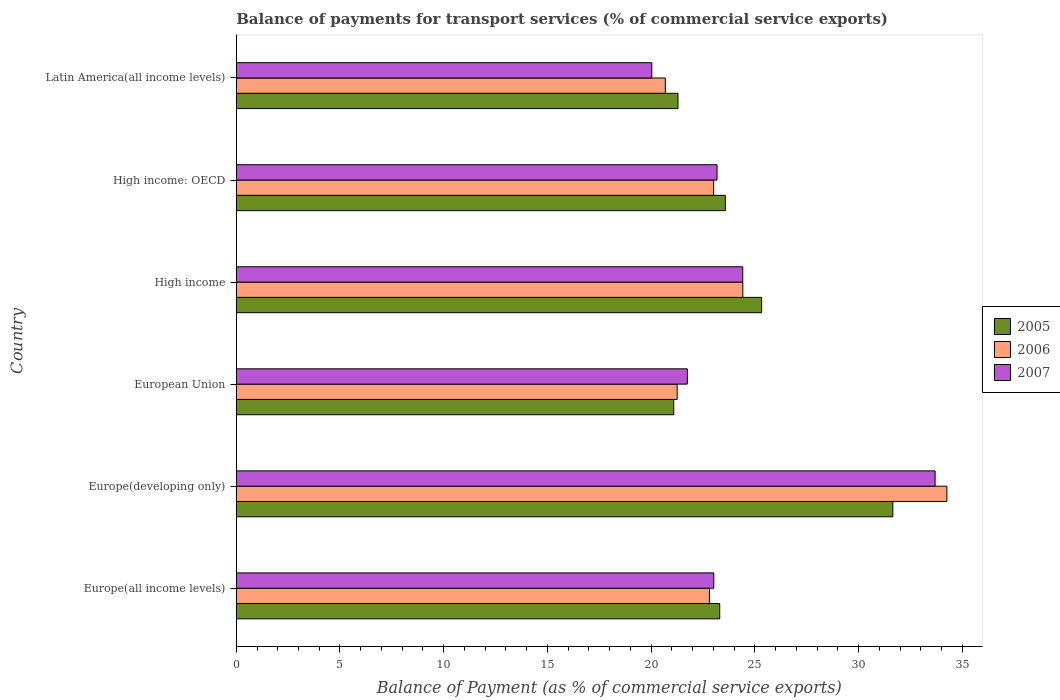Are the number of bars on each tick of the Y-axis equal?
Your response must be concise. Yes. How many bars are there on the 3rd tick from the bottom?
Give a very brief answer. 3. What is the label of the 5th group of bars from the top?
Provide a succinct answer. Europe(developing only). What is the balance of payments for transport services in 2007 in High income?
Provide a short and direct response. 24.42. Across all countries, what is the maximum balance of payments for transport services in 2007?
Your answer should be compact. 33.69. Across all countries, what is the minimum balance of payments for transport services in 2007?
Keep it short and to the point. 20.03. In which country was the balance of payments for transport services in 2006 maximum?
Your response must be concise. Europe(developing only). What is the total balance of payments for transport services in 2007 in the graph?
Ensure brevity in your answer.  146.08. What is the difference between the balance of payments for transport services in 2006 in Europe(all income levels) and that in High income?
Provide a succinct answer. -1.61. What is the difference between the balance of payments for transport services in 2006 in High income: OECD and the balance of payments for transport services in 2005 in Latin America(all income levels)?
Give a very brief answer. 1.72. What is the average balance of payments for transport services in 2005 per country?
Ensure brevity in your answer.  24.37. What is the difference between the balance of payments for transport services in 2007 and balance of payments for transport services in 2005 in High income: OECD?
Provide a short and direct response. -0.4. In how many countries, is the balance of payments for transport services in 2006 greater than 26 %?
Give a very brief answer. 1. What is the ratio of the balance of payments for transport services in 2006 in Europe(developing only) to that in High income: OECD?
Make the answer very short. 1.49. Is the balance of payments for transport services in 2007 in High income: OECD less than that in Latin America(all income levels)?
Your response must be concise. No. What is the difference between the highest and the second highest balance of payments for transport services in 2006?
Keep it short and to the point. 9.84. What is the difference between the highest and the lowest balance of payments for transport services in 2005?
Offer a terse response. 10.56. What does the 2nd bar from the top in High income represents?
Make the answer very short. 2006. Is it the case that in every country, the sum of the balance of payments for transport services in 2005 and balance of payments for transport services in 2006 is greater than the balance of payments for transport services in 2007?
Make the answer very short. Yes. Are all the bars in the graph horizontal?
Your answer should be very brief. Yes. How many countries are there in the graph?
Ensure brevity in your answer.  6. Does the graph contain any zero values?
Your answer should be very brief. No. Does the graph contain grids?
Ensure brevity in your answer.  No. How are the legend labels stacked?
Make the answer very short. Vertical. What is the title of the graph?
Keep it short and to the point. Balance of payments for transport services (% of commercial service exports). Does "1998" appear as one of the legend labels in the graph?
Offer a terse response. No. What is the label or title of the X-axis?
Your answer should be very brief. Balance of Payment (as % of commercial service exports). What is the Balance of Payment (as % of commercial service exports) of 2005 in Europe(all income levels)?
Offer a terse response. 23.31. What is the Balance of Payment (as % of commercial service exports) in 2006 in Europe(all income levels)?
Provide a short and direct response. 22.81. What is the Balance of Payment (as % of commercial service exports) in 2007 in Europe(all income levels)?
Provide a short and direct response. 23.02. What is the Balance of Payment (as % of commercial service exports) of 2005 in Europe(developing only)?
Provide a short and direct response. 31.65. What is the Balance of Payment (as % of commercial service exports) of 2006 in Europe(developing only)?
Your answer should be very brief. 34.26. What is the Balance of Payment (as % of commercial service exports) of 2007 in Europe(developing only)?
Offer a terse response. 33.69. What is the Balance of Payment (as % of commercial service exports) in 2005 in European Union?
Provide a short and direct response. 21.09. What is the Balance of Payment (as % of commercial service exports) of 2006 in European Union?
Give a very brief answer. 21.25. What is the Balance of Payment (as % of commercial service exports) of 2007 in European Union?
Make the answer very short. 21.74. What is the Balance of Payment (as % of commercial service exports) in 2005 in High income?
Provide a succinct answer. 25.33. What is the Balance of Payment (as % of commercial service exports) of 2006 in High income?
Provide a succinct answer. 24.42. What is the Balance of Payment (as % of commercial service exports) of 2007 in High income?
Offer a very short reply. 24.42. What is the Balance of Payment (as % of commercial service exports) of 2005 in High income: OECD?
Offer a very short reply. 23.58. What is the Balance of Payment (as % of commercial service exports) in 2006 in High income: OECD?
Offer a terse response. 23.01. What is the Balance of Payment (as % of commercial service exports) in 2007 in High income: OECD?
Offer a terse response. 23.18. What is the Balance of Payment (as % of commercial service exports) of 2005 in Latin America(all income levels)?
Provide a short and direct response. 21.29. What is the Balance of Payment (as % of commercial service exports) of 2006 in Latin America(all income levels)?
Keep it short and to the point. 20.68. What is the Balance of Payment (as % of commercial service exports) of 2007 in Latin America(all income levels)?
Offer a very short reply. 20.03. Across all countries, what is the maximum Balance of Payment (as % of commercial service exports) of 2005?
Your answer should be very brief. 31.65. Across all countries, what is the maximum Balance of Payment (as % of commercial service exports) in 2006?
Provide a succinct answer. 34.26. Across all countries, what is the maximum Balance of Payment (as % of commercial service exports) in 2007?
Keep it short and to the point. 33.69. Across all countries, what is the minimum Balance of Payment (as % of commercial service exports) of 2005?
Your answer should be compact. 21.09. Across all countries, what is the minimum Balance of Payment (as % of commercial service exports) in 2006?
Offer a very short reply. 20.68. Across all countries, what is the minimum Balance of Payment (as % of commercial service exports) of 2007?
Keep it short and to the point. 20.03. What is the total Balance of Payment (as % of commercial service exports) in 2005 in the graph?
Your answer should be very brief. 146.25. What is the total Balance of Payment (as % of commercial service exports) of 2006 in the graph?
Ensure brevity in your answer.  146.44. What is the total Balance of Payment (as % of commercial service exports) of 2007 in the graph?
Provide a short and direct response. 146.08. What is the difference between the Balance of Payment (as % of commercial service exports) in 2005 in Europe(all income levels) and that in Europe(developing only)?
Keep it short and to the point. -8.35. What is the difference between the Balance of Payment (as % of commercial service exports) of 2006 in Europe(all income levels) and that in Europe(developing only)?
Your answer should be compact. -11.45. What is the difference between the Balance of Payment (as % of commercial service exports) in 2007 in Europe(all income levels) and that in Europe(developing only)?
Your response must be concise. -10.67. What is the difference between the Balance of Payment (as % of commercial service exports) in 2005 in Europe(all income levels) and that in European Union?
Your answer should be compact. 2.22. What is the difference between the Balance of Payment (as % of commercial service exports) in 2006 in Europe(all income levels) and that in European Union?
Keep it short and to the point. 1.55. What is the difference between the Balance of Payment (as % of commercial service exports) of 2007 in Europe(all income levels) and that in European Union?
Your answer should be very brief. 1.28. What is the difference between the Balance of Payment (as % of commercial service exports) in 2005 in Europe(all income levels) and that in High income?
Ensure brevity in your answer.  -2.02. What is the difference between the Balance of Payment (as % of commercial service exports) in 2006 in Europe(all income levels) and that in High income?
Your response must be concise. -1.61. What is the difference between the Balance of Payment (as % of commercial service exports) of 2007 in Europe(all income levels) and that in High income?
Offer a terse response. -1.4. What is the difference between the Balance of Payment (as % of commercial service exports) in 2005 in Europe(all income levels) and that in High income: OECD?
Offer a terse response. -0.27. What is the difference between the Balance of Payment (as % of commercial service exports) in 2006 in Europe(all income levels) and that in High income: OECD?
Offer a very short reply. -0.2. What is the difference between the Balance of Payment (as % of commercial service exports) of 2007 in Europe(all income levels) and that in High income: OECD?
Keep it short and to the point. -0.16. What is the difference between the Balance of Payment (as % of commercial service exports) in 2005 in Europe(all income levels) and that in Latin America(all income levels)?
Your answer should be very brief. 2.01. What is the difference between the Balance of Payment (as % of commercial service exports) in 2006 in Europe(all income levels) and that in Latin America(all income levels)?
Provide a short and direct response. 2.13. What is the difference between the Balance of Payment (as % of commercial service exports) of 2007 in Europe(all income levels) and that in Latin America(all income levels)?
Offer a very short reply. 2.99. What is the difference between the Balance of Payment (as % of commercial service exports) in 2005 in Europe(developing only) and that in European Union?
Make the answer very short. 10.56. What is the difference between the Balance of Payment (as % of commercial service exports) in 2006 in Europe(developing only) and that in European Union?
Your answer should be compact. 13. What is the difference between the Balance of Payment (as % of commercial service exports) in 2007 in Europe(developing only) and that in European Union?
Ensure brevity in your answer.  11.94. What is the difference between the Balance of Payment (as % of commercial service exports) in 2005 in Europe(developing only) and that in High income?
Your answer should be compact. 6.33. What is the difference between the Balance of Payment (as % of commercial service exports) of 2006 in Europe(developing only) and that in High income?
Provide a short and direct response. 9.84. What is the difference between the Balance of Payment (as % of commercial service exports) of 2007 in Europe(developing only) and that in High income?
Ensure brevity in your answer.  9.27. What is the difference between the Balance of Payment (as % of commercial service exports) of 2005 in Europe(developing only) and that in High income: OECD?
Your answer should be compact. 8.07. What is the difference between the Balance of Payment (as % of commercial service exports) in 2006 in Europe(developing only) and that in High income: OECD?
Keep it short and to the point. 11.25. What is the difference between the Balance of Payment (as % of commercial service exports) in 2007 in Europe(developing only) and that in High income: OECD?
Your answer should be compact. 10.51. What is the difference between the Balance of Payment (as % of commercial service exports) in 2005 in Europe(developing only) and that in Latin America(all income levels)?
Offer a very short reply. 10.36. What is the difference between the Balance of Payment (as % of commercial service exports) of 2006 in Europe(developing only) and that in Latin America(all income levels)?
Give a very brief answer. 13.57. What is the difference between the Balance of Payment (as % of commercial service exports) in 2007 in Europe(developing only) and that in Latin America(all income levels)?
Your answer should be compact. 13.66. What is the difference between the Balance of Payment (as % of commercial service exports) in 2005 in European Union and that in High income?
Keep it short and to the point. -4.24. What is the difference between the Balance of Payment (as % of commercial service exports) of 2006 in European Union and that in High income?
Keep it short and to the point. -3.17. What is the difference between the Balance of Payment (as % of commercial service exports) in 2007 in European Union and that in High income?
Your answer should be very brief. -2.67. What is the difference between the Balance of Payment (as % of commercial service exports) of 2005 in European Union and that in High income: OECD?
Offer a terse response. -2.49. What is the difference between the Balance of Payment (as % of commercial service exports) of 2006 in European Union and that in High income: OECD?
Make the answer very short. -1.76. What is the difference between the Balance of Payment (as % of commercial service exports) in 2007 in European Union and that in High income: OECD?
Provide a short and direct response. -1.43. What is the difference between the Balance of Payment (as % of commercial service exports) of 2005 in European Union and that in Latin America(all income levels)?
Make the answer very short. -0.21. What is the difference between the Balance of Payment (as % of commercial service exports) of 2006 in European Union and that in Latin America(all income levels)?
Your answer should be compact. 0.57. What is the difference between the Balance of Payment (as % of commercial service exports) of 2007 in European Union and that in Latin America(all income levels)?
Provide a short and direct response. 1.71. What is the difference between the Balance of Payment (as % of commercial service exports) of 2005 in High income and that in High income: OECD?
Ensure brevity in your answer.  1.75. What is the difference between the Balance of Payment (as % of commercial service exports) in 2006 in High income and that in High income: OECD?
Your response must be concise. 1.41. What is the difference between the Balance of Payment (as % of commercial service exports) in 2007 in High income and that in High income: OECD?
Give a very brief answer. 1.24. What is the difference between the Balance of Payment (as % of commercial service exports) of 2005 in High income and that in Latin America(all income levels)?
Your answer should be compact. 4.03. What is the difference between the Balance of Payment (as % of commercial service exports) of 2006 in High income and that in Latin America(all income levels)?
Provide a short and direct response. 3.74. What is the difference between the Balance of Payment (as % of commercial service exports) in 2007 in High income and that in Latin America(all income levels)?
Make the answer very short. 4.38. What is the difference between the Balance of Payment (as % of commercial service exports) in 2005 in High income: OECD and that in Latin America(all income levels)?
Make the answer very short. 2.28. What is the difference between the Balance of Payment (as % of commercial service exports) in 2006 in High income: OECD and that in Latin America(all income levels)?
Give a very brief answer. 2.33. What is the difference between the Balance of Payment (as % of commercial service exports) of 2007 in High income: OECD and that in Latin America(all income levels)?
Give a very brief answer. 3.15. What is the difference between the Balance of Payment (as % of commercial service exports) in 2005 in Europe(all income levels) and the Balance of Payment (as % of commercial service exports) in 2006 in Europe(developing only)?
Your response must be concise. -10.95. What is the difference between the Balance of Payment (as % of commercial service exports) of 2005 in Europe(all income levels) and the Balance of Payment (as % of commercial service exports) of 2007 in Europe(developing only)?
Provide a succinct answer. -10.38. What is the difference between the Balance of Payment (as % of commercial service exports) of 2006 in Europe(all income levels) and the Balance of Payment (as % of commercial service exports) of 2007 in Europe(developing only)?
Offer a terse response. -10.88. What is the difference between the Balance of Payment (as % of commercial service exports) in 2005 in Europe(all income levels) and the Balance of Payment (as % of commercial service exports) in 2006 in European Union?
Your answer should be compact. 2.05. What is the difference between the Balance of Payment (as % of commercial service exports) in 2005 in Europe(all income levels) and the Balance of Payment (as % of commercial service exports) in 2007 in European Union?
Your answer should be compact. 1.56. What is the difference between the Balance of Payment (as % of commercial service exports) in 2006 in Europe(all income levels) and the Balance of Payment (as % of commercial service exports) in 2007 in European Union?
Your response must be concise. 1.06. What is the difference between the Balance of Payment (as % of commercial service exports) of 2005 in Europe(all income levels) and the Balance of Payment (as % of commercial service exports) of 2006 in High income?
Your response must be concise. -1.11. What is the difference between the Balance of Payment (as % of commercial service exports) of 2005 in Europe(all income levels) and the Balance of Payment (as % of commercial service exports) of 2007 in High income?
Your response must be concise. -1.11. What is the difference between the Balance of Payment (as % of commercial service exports) of 2006 in Europe(all income levels) and the Balance of Payment (as % of commercial service exports) of 2007 in High income?
Make the answer very short. -1.61. What is the difference between the Balance of Payment (as % of commercial service exports) of 2005 in Europe(all income levels) and the Balance of Payment (as % of commercial service exports) of 2006 in High income: OECD?
Ensure brevity in your answer.  0.29. What is the difference between the Balance of Payment (as % of commercial service exports) in 2005 in Europe(all income levels) and the Balance of Payment (as % of commercial service exports) in 2007 in High income: OECD?
Your response must be concise. 0.13. What is the difference between the Balance of Payment (as % of commercial service exports) of 2006 in Europe(all income levels) and the Balance of Payment (as % of commercial service exports) of 2007 in High income: OECD?
Provide a succinct answer. -0.37. What is the difference between the Balance of Payment (as % of commercial service exports) in 2005 in Europe(all income levels) and the Balance of Payment (as % of commercial service exports) in 2006 in Latin America(all income levels)?
Offer a very short reply. 2.62. What is the difference between the Balance of Payment (as % of commercial service exports) in 2005 in Europe(all income levels) and the Balance of Payment (as % of commercial service exports) in 2007 in Latin America(all income levels)?
Give a very brief answer. 3.27. What is the difference between the Balance of Payment (as % of commercial service exports) in 2006 in Europe(all income levels) and the Balance of Payment (as % of commercial service exports) in 2007 in Latin America(all income levels)?
Make the answer very short. 2.78. What is the difference between the Balance of Payment (as % of commercial service exports) of 2005 in Europe(developing only) and the Balance of Payment (as % of commercial service exports) of 2006 in European Union?
Offer a terse response. 10.4. What is the difference between the Balance of Payment (as % of commercial service exports) of 2005 in Europe(developing only) and the Balance of Payment (as % of commercial service exports) of 2007 in European Union?
Your answer should be compact. 9.91. What is the difference between the Balance of Payment (as % of commercial service exports) of 2006 in Europe(developing only) and the Balance of Payment (as % of commercial service exports) of 2007 in European Union?
Make the answer very short. 12.51. What is the difference between the Balance of Payment (as % of commercial service exports) of 2005 in Europe(developing only) and the Balance of Payment (as % of commercial service exports) of 2006 in High income?
Your answer should be compact. 7.23. What is the difference between the Balance of Payment (as % of commercial service exports) of 2005 in Europe(developing only) and the Balance of Payment (as % of commercial service exports) of 2007 in High income?
Keep it short and to the point. 7.24. What is the difference between the Balance of Payment (as % of commercial service exports) in 2006 in Europe(developing only) and the Balance of Payment (as % of commercial service exports) in 2007 in High income?
Offer a terse response. 9.84. What is the difference between the Balance of Payment (as % of commercial service exports) in 2005 in Europe(developing only) and the Balance of Payment (as % of commercial service exports) in 2006 in High income: OECD?
Make the answer very short. 8.64. What is the difference between the Balance of Payment (as % of commercial service exports) in 2005 in Europe(developing only) and the Balance of Payment (as % of commercial service exports) in 2007 in High income: OECD?
Make the answer very short. 8.48. What is the difference between the Balance of Payment (as % of commercial service exports) of 2006 in Europe(developing only) and the Balance of Payment (as % of commercial service exports) of 2007 in High income: OECD?
Keep it short and to the point. 11.08. What is the difference between the Balance of Payment (as % of commercial service exports) in 2005 in Europe(developing only) and the Balance of Payment (as % of commercial service exports) in 2006 in Latin America(all income levels)?
Your answer should be very brief. 10.97. What is the difference between the Balance of Payment (as % of commercial service exports) of 2005 in Europe(developing only) and the Balance of Payment (as % of commercial service exports) of 2007 in Latin America(all income levels)?
Your response must be concise. 11.62. What is the difference between the Balance of Payment (as % of commercial service exports) of 2006 in Europe(developing only) and the Balance of Payment (as % of commercial service exports) of 2007 in Latin America(all income levels)?
Offer a very short reply. 14.23. What is the difference between the Balance of Payment (as % of commercial service exports) of 2005 in European Union and the Balance of Payment (as % of commercial service exports) of 2006 in High income?
Ensure brevity in your answer.  -3.33. What is the difference between the Balance of Payment (as % of commercial service exports) in 2005 in European Union and the Balance of Payment (as % of commercial service exports) in 2007 in High income?
Ensure brevity in your answer.  -3.33. What is the difference between the Balance of Payment (as % of commercial service exports) in 2006 in European Union and the Balance of Payment (as % of commercial service exports) in 2007 in High income?
Your response must be concise. -3.16. What is the difference between the Balance of Payment (as % of commercial service exports) of 2005 in European Union and the Balance of Payment (as % of commercial service exports) of 2006 in High income: OECD?
Provide a succinct answer. -1.92. What is the difference between the Balance of Payment (as % of commercial service exports) in 2005 in European Union and the Balance of Payment (as % of commercial service exports) in 2007 in High income: OECD?
Offer a very short reply. -2.09. What is the difference between the Balance of Payment (as % of commercial service exports) in 2006 in European Union and the Balance of Payment (as % of commercial service exports) in 2007 in High income: OECD?
Your answer should be very brief. -1.92. What is the difference between the Balance of Payment (as % of commercial service exports) in 2005 in European Union and the Balance of Payment (as % of commercial service exports) in 2006 in Latin America(all income levels)?
Make the answer very short. 0.41. What is the difference between the Balance of Payment (as % of commercial service exports) of 2005 in European Union and the Balance of Payment (as % of commercial service exports) of 2007 in Latin America(all income levels)?
Provide a short and direct response. 1.06. What is the difference between the Balance of Payment (as % of commercial service exports) in 2006 in European Union and the Balance of Payment (as % of commercial service exports) in 2007 in Latin America(all income levels)?
Keep it short and to the point. 1.22. What is the difference between the Balance of Payment (as % of commercial service exports) in 2005 in High income and the Balance of Payment (as % of commercial service exports) in 2006 in High income: OECD?
Offer a very short reply. 2.31. What is the difference between the Balance of Payment (as % of commercial service exports) of 2005 in High income and the Balance of Payment (as % of commercial service exports) of 2007 in High income: OECD?
Ensure brevity in your answer.  2.15. What is the difference between the Balance of Payment (as % of commercial service exports) in 2006 in High income and the Balance of Payment (as % of commercial service exports) in 2007 in High income: OECD?
Offer a terse response. 1.24. What is the difference between the Balance of Payment (as % of commercial service exports) in 2005 in High income and the Balance of Payment (as % of commercial service exports) in 2006 in Latin America(all income levels)?
Make the answer very short. 4.64. What is the difference between the Balance of Payment (as % of commercial service exports) in 2005 in High income and the Balance of Payment (as % of commercial service exports) in 2007 in Latin America(all income levels)?
Your answer should be compact. 5.29. What is the difference between the Balance of Payment (as % of commercial service exports) of 2006 in High income and the Balance of Payment (as % of commercial service exports) of 2007 in Latin America(all income levels)?
Ensure brevity in your answer.  4.39. What is the difference between the Balance of Payment (as % of commercial service exports) in 2005 in High income: OECD and the Balance of Payment (as % of commercial service exports) in 2006 in Latin America(all income levels)?
Offer a very short reply. 2.9. What is the difference between the Balance of Payment (as % of commercial service exports) of 2005 in High income: OECD and the Balance of Payment (as % of commercial service exports) of 2007 in Latin America(all income levels)?
Keep it short and to the point. 3.55. What is the difference between the Balance of Payment (as % of commercial service exports) of 2006 in High income: OECD and the Balance of Payment (as % of commercial service exports) of 2007 in Latin America(all income levels)?
Ensure brevity in your answer.  2.98. What is the average Balance of Payment (as % of commercial service exports) of 2005 per country?
Keep it short and to the point. 24.37. What is the average Balance of Payment (as % of commercial service exports) in 2006 per country?
Provide a short and direct response. 24.41. What is the average Balance of Payment (as % of commercial service exports) of 2007 per country?
Make the answer very short. 24.35. What is the difference between the Balance of Payment (as % of commercial service exports) in 2005 and Balance of Payment (as % of commercial service exports) in 2006 in Europe(all income levels)?
Provide a succinct answer. 0.5. What is the difference between the Balance of Payment (as % of commercial service exports) in 2005 and Balance of Payment (as % of commercial service exports) in 2007 in Europe(all income levels)?
Keep it short and to the point. 0.29. What is the difference between the Balance of Payment (as % of commercial service exports) in 2006 and Balance of Payment (as % of commercial service exports) in 2007 in Europe(all income levels)?
Offer a terse response. -0.21. What is the difference between the Balance of Payment (as % of commercial service exports) of 2005 and Balance of Payment (as % of commercial service exports) of 2006 in Europe(developing only)?
Your answer should be very brief. -2.6. What is the difference between the Balance of Payment (as % of commercial service exports) in 2005 and Balance of Payment (as % of commercial service exports) in 2007 in Europe(developing only)?
Ensure brevity in your answer.  -2.04. What is the difference between the Balance of Payment (as % of commercial service exports) of 2006 and Balance of Payment (as % of commercial service exports) of 2007 in Europe(developing only)?
Give a very brief answer. 0.57. What is the difference between the Balance of Payment (as % of commercial service exports) of 2005 and Balance of Payment (as % of commercial service exports) of 2006 in European Union?
Your answer should be compact. -0.17. What is the difference between the Balance of Payment (as % of commercial service exports) in 2005 and Balance of Payment (as % of commercial service exports) in 2007 in European Union?
Make the answer very short. -0.66. What is the difference between the Balance of Payment (as % of commercial service exports) in 2006 and Balance of Payment (as % of commercial service exports) in 2007 in European Union?
Give a very brief answer. -0.49. What is the difference between the Balance of Payment (as % of commercial service exports) in 2005 and Balance of Payment (as % of commercial service exports) in 2006 in High income?
Provide a short and direct response. 0.91. What is the difference between the Balance of Payment (as % of commercial service exports) of 2005 and Balance of Payment (as % of commercial service exports) of 2007 in High income?
Keep it short and to the point. 0.91. What is the difference between the Balance of Payment (as % of commercial service exports) of 2006 and Balance of Payment (as % of commercial service exports) of 2007 in High income?
Your answer should be compact. 0. What is the difference between the Balance of Payment (as % of commercial service exports) of 2005 and Balance of Payment (as % of commercial service exports) of 2006 in High income: OECD?
Keep it short and to the point. 0.57. What is the difference between the Balance of Payment (as % of commercial service exports) of 2005 and Balance of Payment (as % of commercial service exports) of 2007 in High income: OECD?
Your response must be concise. 0.4. What is the difference between the Balance of Payment (as % of commercial service exports) of 2006 and Balance of Payment (as % of commercial service exports) of 2007 in High income: OECD?
Your answer should be compact. -0.17. What is the difference between the Balance of Payment (as % of commercial service exports) in 2005 and Balance of Payment (as % of commercial service exports) in 2006 in Latin America(all income levels)?
Make the answer very short. 0.61. What is the difference between the Balance of Payment (as % of commercial service exports) of 2005 and Balance of Payment (as % of commercial service exports) of 2007 in Latin America(all income levels)?
Your response must be concise. 1.26. What is the difference between the Balance of Payment (as % of commercial service exports) of 2006 and Balance of Payment (as % of commercial service exports) of 2007 in Latin America(all income levels)?
Your answer should be very brief. 0.65. What is the ratio of the Balance of Payment (as % of commercial service exports) of 2005 in Europe(all income levels) to that in Europe(developing only)?
Your response must be concise. 0.74. What is the ratio of the Balance of Payment (as % of commercial service exports) in 2006 in Europe(all income levels) to that in Europe(developing only)?
Offer a very short reply. 0.67. What is the ratio of the Balance of Payment (as % of commercial service exports) of 2007 in Europe(all income levels) to that in Europe(developing only)?
Keep it short and to the point. 0.68. What is the ratio of the Balance of Payment (as % of commercial service exports) of 2005 in Europe(all income levels) to that in European Union?
Offer a very short reply. 1.11. What is the ratio of the Balance of Payment (as % of commercial service exports) in 2006 in Europe(all income levels) to that in European Union?
Make the answer very short. 1.07. What is the ratio of the Balance of Payment (as % of commercial service exports) of 2007 in Europe(all income levels) to that in European Union?
Offer a very short reply. 1.06. What is the ratio of the Balance of Payment (as % of commercial service exports) in 2005 in Europe(all income levels) to that in High income?
Offer a very short reply. 0.92. What is the ratio of the Balance of Payment (as % of commercial service exports) in 2006 in Europe(all income levels) to that in High income?
Offer a terse response. 0.93. What is the ratio of the Balance of Payment (as % of commercial service exports) of 2007 in Europe(all income levels) to that in High income?
Provide a short and direct response. 0.94. What is the ratio of the Balance of Payment (as % of commercial service exports) of 2005 in Europe(all income levels) to that in High income: OECD?
Your answer should be very brief. 0.99. What is the ratio of the Balance of Payment (as % of commercial service exports) of 2005 in Europe(all income levels) to that in Latin America(all income levels)?
Your response must be concise. 1.09. What is the ratio of the Balance of Payment (as % of commercial service exports) of 2006 in Europe(all income levels) to that in Latin America(all income levels)?
Your answer should be compact. 1.1. What is the ratio of the Balance of Payment (as % of commercial service exports) in 2007 in Europe(all income levels) to that in Latin America(all income levels)?
Offer a terse response. 1.15. What is the ratio of the Balance of Payment (as % of commercial service exports) of 2005 in Europe(developing only) to that in European Union?
Your answer should be very brief. 1.5. What is the ratio of the Balance of Payment (as % of commercial service exports) in 2006 in Europe(developing only) to that in European Union?
Make the answer very short. 1.61. What is the ratio of the Balance of Payment (as % of commercial service exports) in 2007 in Europe(developing only) to that in European Union?
Give a very brief answer. 1.55. What is the ratio of the Balance of Payment (as % of commercial service exports) of 2005 in Europe(developing only) to that in High income?
Ensure brevity in your answer.  1.25. What is the ratio of the Balance of Payment (as % of commercial service exports) in 2006 in Europe(developing only) to that in High income?
Ensure brevity in your answer.  1.4. What is the ratio of the Balance of Payment (as % of commercial service exports) in 2007 in Europe(developing only) to that in High income?
Ensure brevity in your answer.  1.38. What is the ratio of the Balance of Payment (as % of commercial service exports) of 2005 in Europe(developing only) to that in High income: OECD?
Keep it short and to the point. 1.34. What is the ratio of the Balance of Payment (as % of commercial service exports) of 2006 in Europe(developing only) to that in High income: OECD?
Ensure brevity in your answer.  1.49. What is the ratio of the Balance of Payment (as % of commercial service exports) in 2007 in Europe(developing only) to that in High income: OECD?
Your answer should be compact. 1.45. What is the ratio of the Balance of Payment (as % of commercial service exports) in 2005 in Europe(developing only) to that in Latin America(all income levels)?
Offer a terse response. 1.49. What is the ratio of the Balance of Payment (as % of commercial service exports) of 2006 in Europe(developing only) to that in Latin America(all income levels)?
Provide a short and direct response. 1.66. What is the ratio of the Balance of Payment (as % of commercial service exports) of 2007 in Europe(developing only) to that in Latin America(all income levels)?
Offer a terse response. 1.68. What is the ratio of the Balance of Payment (as % of commercial service exports) in 2005 in European Union to that in High income?
Your answer should be very brief. 0.83. What is the ratio of the Balance of Payment (as % of commercial service exports) of 2006 in European Union to that in High income?
Provide a succinct answer. 0.87. What is the ratio of the Balance of Payment (as % of commercial service exports) of 2007 in European Union to that in High income?
Give a very brief answer. 0.89. What is the ratio of the Balance of Payment (as % of commercial service exports) in 2005 in European Union to that in High income: OECD?
Make the answer very short. 0.89. What is the ratio of the Balance of Payment (as % of commercial service exports) of 2006 in European Union to that in High income: OECD?
Your answer should be compact. 0.92. What is the ratio of the Balance of Payment (as % of commercial service exports) in 2007 in European Union to that in High income: OECD?
Provide a short and direct response. 0.94. What is the ratio of the Balance of Payment (as % of commercial service exports) of 2005 in European Union to that in Latin America(all income levels)?
Give a very brief answer. 0.99. What is the ratio of the Balance of Payment (as % of commercial service exports) in 2006 in European Union to that in Latin America(all income levels)?
Keep it short and to the point. 1.03. What is the ratio of the Balance of Payment (as % of commercial service exports) in 2007 in European Union to that in Latin America(all income levels)?
Give a very brief answer. 1.09. What is the ratio of the Balance of Payment (as % of commercial service exports) of 2005 in High income to that in High income: OECD?
Provide a short and direct response. 1.07. What is the ratio of the Balance of Payment (as % of commercial service exports) in 2006 in High income to that in High income: OECD?
Make the answer very short. 1.06. What is the ratio of the Balance of Payment (as % of commercial service exports) in 2007 in High income to that in High income: OECD?
Ensure brevity in your answer.  1.05. What is the ratio of the Balance of Payment (as % of commercial service exports) of 2005 in High income to that in Latin America(all income levels)?
Ensure brevity in your answer.  1.19. What is the ratio of the Balance of Payment (as % of commercial service exports) of 2006 in High income to that in Latin America(all income levels)?
Your answer should be compact. 1.18. What is the ratio of the Balance of Payment (as % of commercial service exports) in 2007 in High income to that in Latin America(all income levels)?
Ensure brevity in your answer.  1.22. What is the ratio of the Balance of Payment (as % of commercial service exports) in 2005 in High income: OECD to that in Latin America(all income levels)?
Ensure brevity in your answer.  1.11. What is the ratio of the Balance of Payment (as % of commercial service exports) in 2006 in High income: OECD to that in Latin America(all income levels)?
Ensure brevity in your answer.  1.11. What is the ratio of the Balance of Payment (as % of commercial service exports) of 2007 in High income: OECD to that in Latin America(all income levels)?
Give a very brief answer. 1.16. What is the difference between the highest and the second highest Balance of Payment (as % of commercial service exports) in 2005?
Provide a short and direct response. 6.33. What is the difference between the highest and the second highest Balance of Payment (as % of commercial service exports) of 2006?
Give a very brief answer. 9.84. What is the difference between the highest and the second highest Balance of Payment (as % of commercial service exports) of 2007?
Provide a short and direct response. 9.27. What is the difference between the highest and the lowest Balance of Payment (as % of commercial service exports) in 2005?
Your answer should be very brief. 10.56. What is the difference between the highest and the lowest Balance of Payment (as % of commercial service exports) of 2006?
Provide a short and direct response. 13.57. What is the difference between the highest and the lowest Balance of Payment (as % of commercial service exports) in 2007?
Offer a terse response. 13.66. 